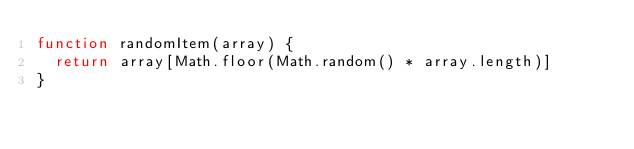Convert code to text. <code><loc_0><loc_0><loc_500><loc_500><_JavaScript_>function randomItem(array) {
  return array[Math.floor(Math.random() * array.length)]
}</code> 